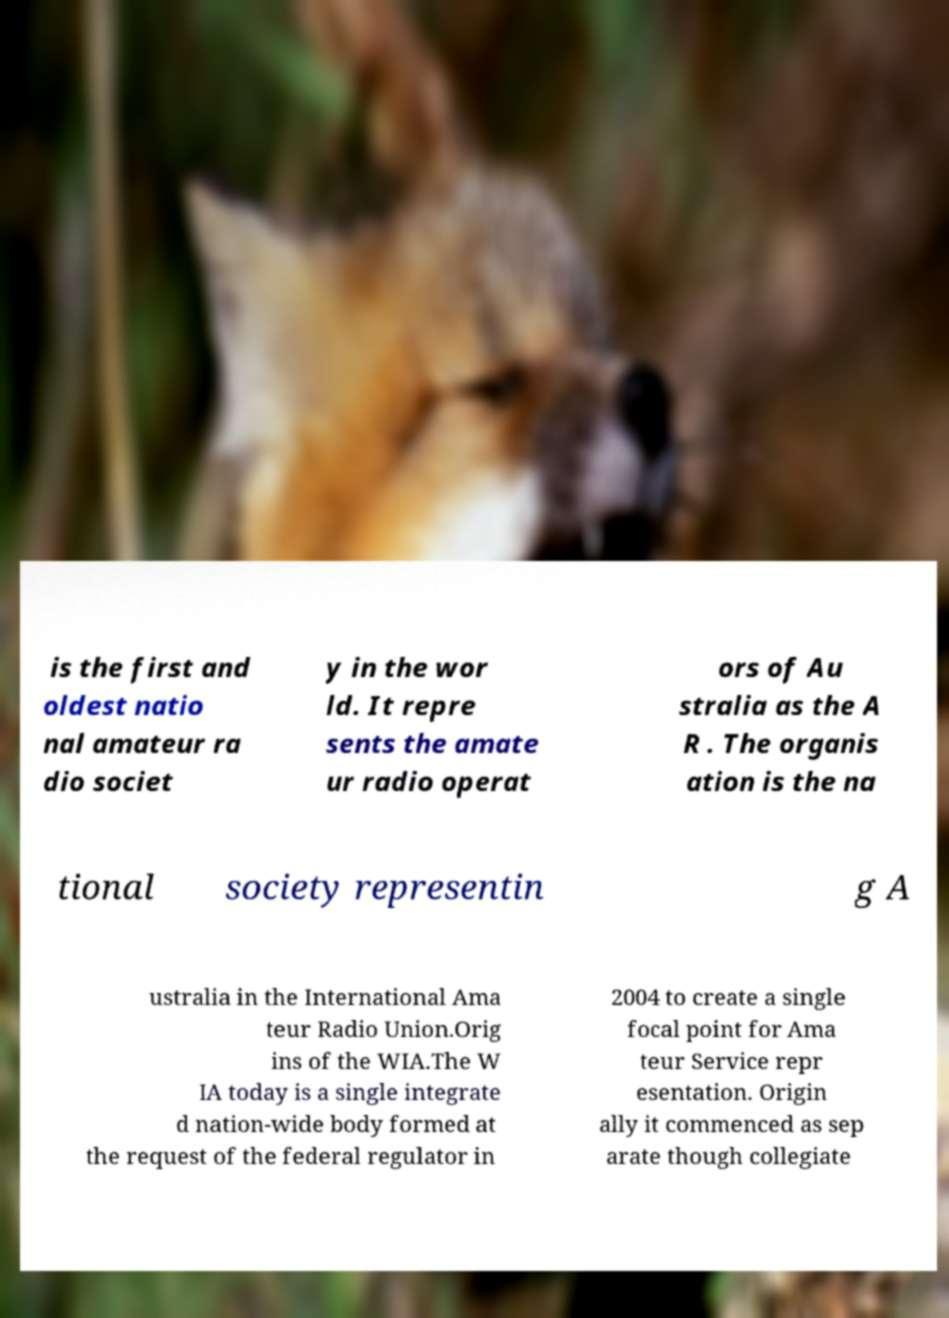For documentation purposes, I need the text within this image transcribed. Could you provide that? is the first and oldest natio nal amateur ra dio societ y in the wor ld. It repre sents the amate ur radio operat ors of Au stralia as the A R . The organis ation is the na tional society representin g A ustralia in the International Ama teur Radio Union.Orig ins of the WIA.The W IA today is a single integrate d nation-wide body formed at the request of the federal regulator in 2004 to create a single focal point for Ama teur Service repr esentation. Origin ally it commenced as sep arate though collegiate 